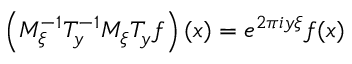Convert formula to latex. <formula><loc_0><loc_0><loc_500><loc_500>\left ( M _ { \xi } ^ { - 1 } T _ { y } ^ { - 1 } M _ { \xi } T _ { y } f \right ) ( x ) = e ^ { 2 \pi i y \xi } f ( x )</formula> 